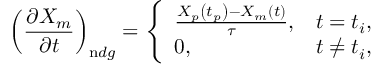Convert formula to latex. <formula><loc_0><loc_0><loc_500><loc_500>\left ( \frac { \partial X _ { m } } { \partial t } \right ) _ { n d g } = \left \{ \begin{array} { l l } { \frac { X _ { p } \left ( t _ { p } \right ) - X _ { m } ( t ) } { \tau } , } & { t = t _ { i } , } \\ { 0 , } & { t \neq t _ { i } , } \end{array}</formula> 